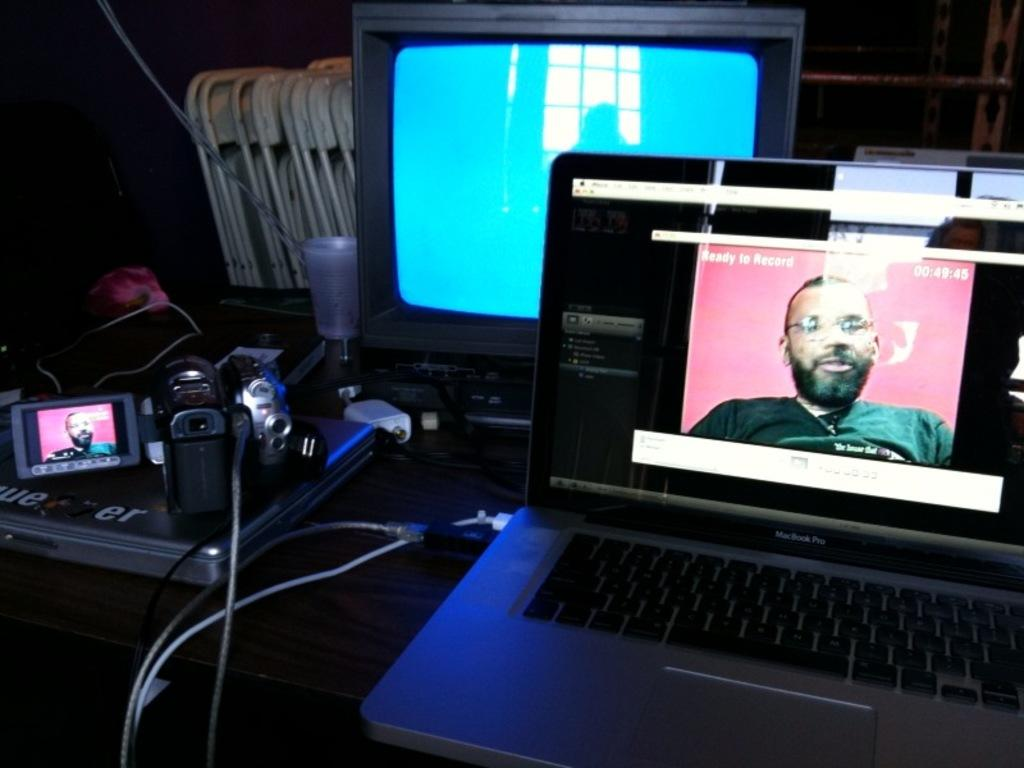<image>
Share a concise interpretation of the image provided. Macbook Pro monitor showing a man in front of a pink background. 